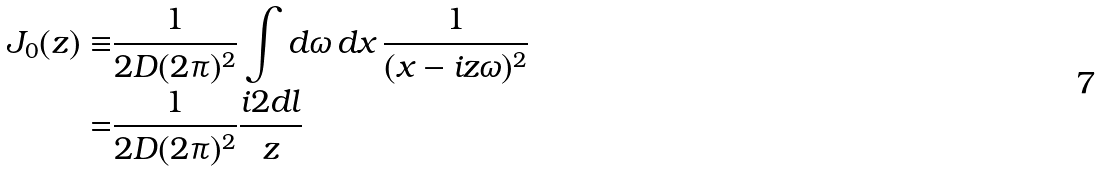Convert formula to latex. <formula><loc_0><loc_0><loc_500><loc_500>J _ { 0 } ( z ) \equiv & \frac { 1 } { 2 D ( 2 \pi ) ^ { 2 } } \int d \omega \, d x \, \frac { 1 } { ( x - i z \omega ) ^ { 2 } } \\ = & \frac { 1 } { 2 D ( 2 \pi ) ^ { 2 } } \frac { i 2 d l } { z }</formula> 